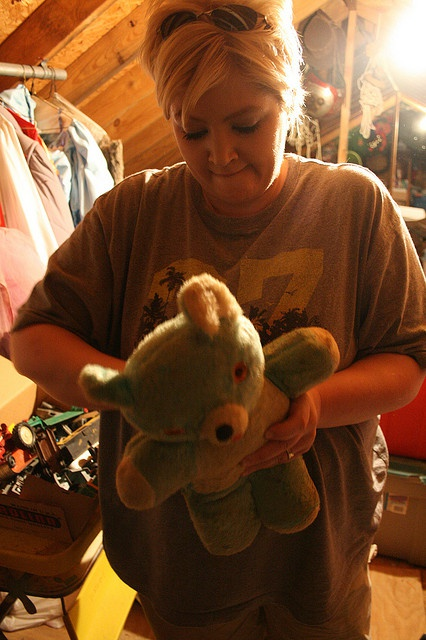Describe the objects in this image and their specific colors. I can see people in orange, maroon, black, and brown tones and teddy bear in orange, black, maroon, and brown tones in this image. 